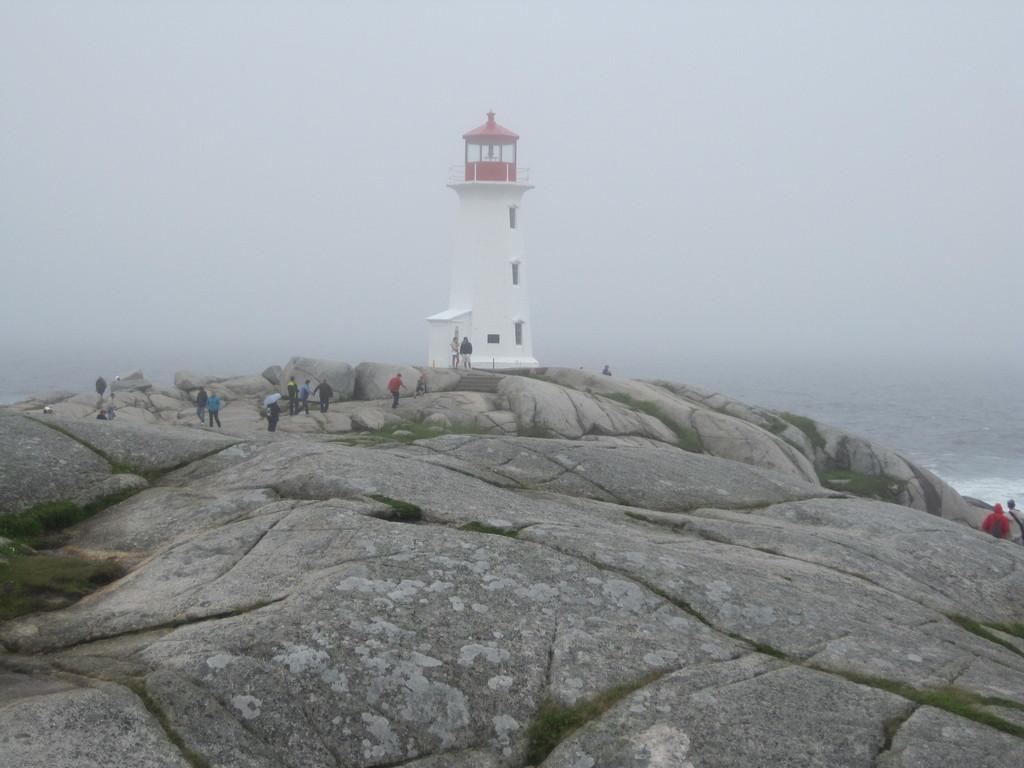What is the main structure in the image? There is a lighthouse in the image. What are the people in the image doing? There are people walking in the image. What type of natural feature can be seen in the image? There is water visible in the image. What else can be seen in the image besides the lighthouse and people? There are rocks in the image. What is the color of the sky in the image? The sky is white in color. What type of pet can be seen playing with the people in the image? There is no pet visible in the image; only the lighthouse, people, water, rocks, and the white sky are present. 